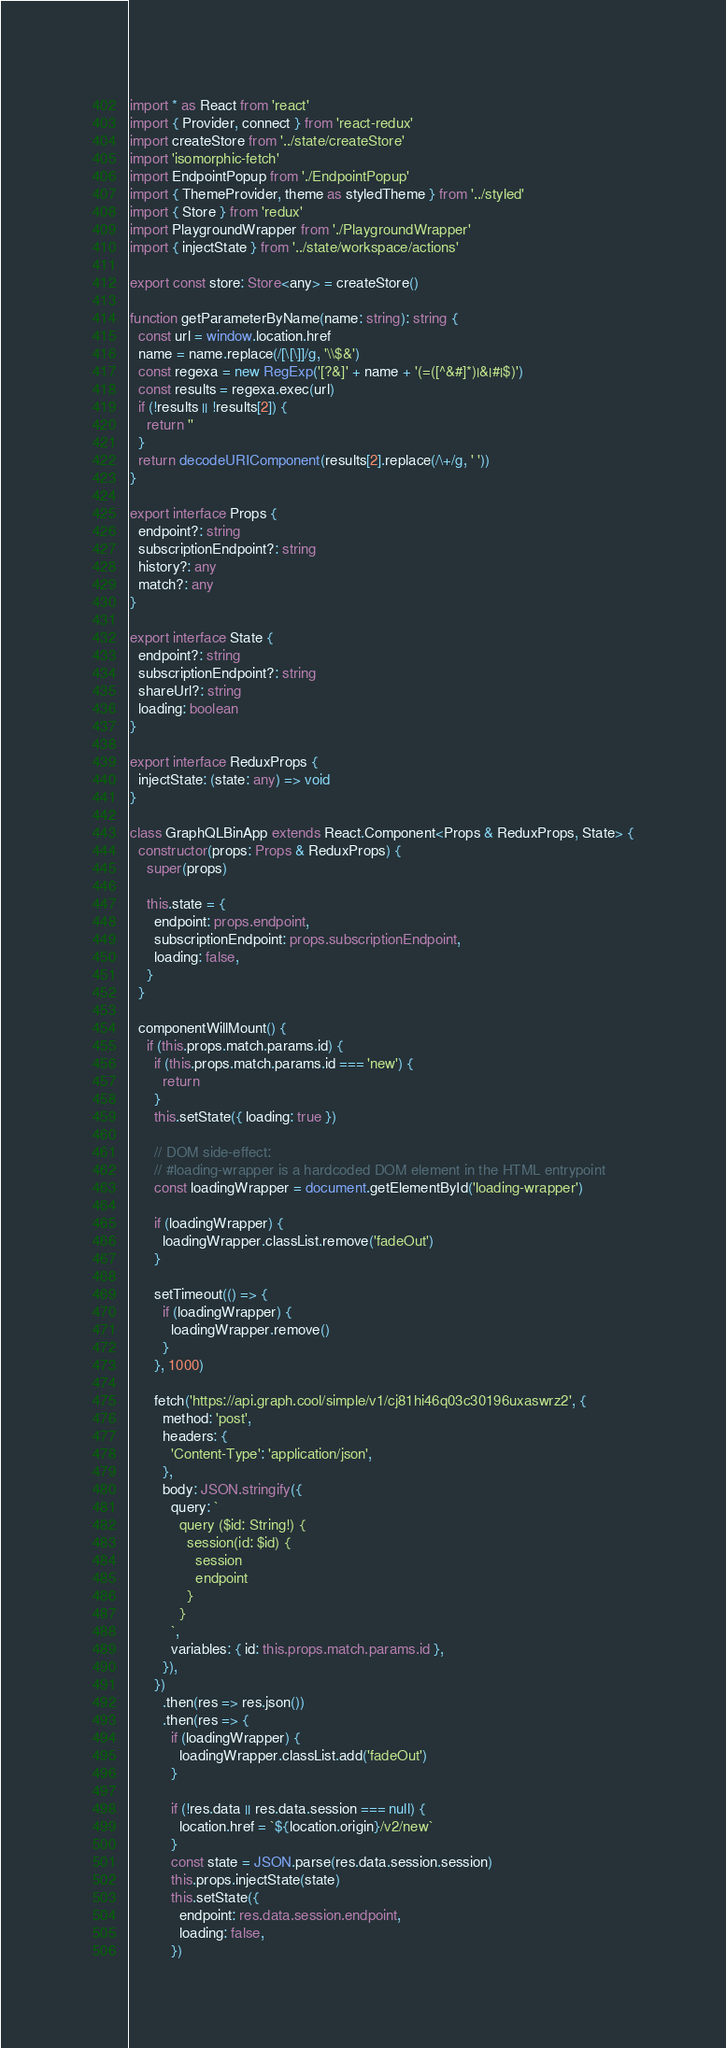Convert code to text. <code><loc_0><loc_0><loc_500><loc_500><_TypeScript_>import * as React from 'react'
import { Provider, connect } from 'react-redux'
import createStore from '../state/createStore'
import 'isomorphic-fetch'
import EndpointPopup from './EndpointPopup'
import { ThemeProvider, theme as styledTheme } from '../styled'
import { Store } from 'redux'
import PlaygroundWrapper from './PlaygroundWrapper'
import { injectState } from '../state/workspace/actions'

export const store: Store<any> = createStore()

function getParameterByName(name: string): string {
  const url = window.location.href
  name = name.replace(/[\[\]]/g, '\\$&')
  const regexa = new RegExp('[?&]' + name + '(=([^&#]*)|&|#|$)')
  const results = regexa.exec(url)
  if (!results || !results[2]) {
    return ''
  }
  return decodeURIComponent(results[2].replace(/\+/g, ' '))
}

export interface Props {
  endpoint?: string
  subscriptionEndpoint?: string
  history?: any
  match?: any
}

export interface State {
  endpoint?: string
  subscriptionEndpoint?: string
  shareUrl?: string
  loading: boolean
}

export interface ReduxProps {
  injectState: (state: any) => void
}

class GraphQLBinApp extends React.Component<Props & ReduxProps, State> {
  constructor(props: Props & ReduxProps) {
    super(props)

    this.state = {
      endpoint: props.endpoint,
      subscriptionEndpoint: props.subscriptionEndpoint,
      loading: false,
    }
  }

  componentWillMount() {
    if (this.props.match.params.id) {
      if (this.props.match.params.id === 'new') {
        return
      }
      this.setState({ loading: true })

      // DOM side-effect:
      // #loading-wrapper is a hardcoded DOM element in the HTML entrypoint
      const loadingWrapper = document.getElementById('loading-wrapper')

      if (loadingWrapper) {
        loadingWrapper.classList.remove('fadeOut')
      }

      setTimeout(() => {
        if (loadingWrapper) {
          loadingWrapper.remove()
        }
      }, 1000)

      fetch('https://api.graph.cool/simple/v1/cj81hi46q03c30196uxaswrz2', {
        method: 'post',
        headers: {
          'Content-Type': 'application/json',
        },
        body: JSON.stringify({
          query: `
            query ($id: String!) {
              session(id: $id) {
                session
                endpoint
              }
            }
          `,
          variables: { id: this.props.match.params.id },
        }),
      })
        .then(res => res.json())
        .then(res => {
          if (loadingWrapper) {
            loadingWrapper.classList.add('fadeOut')
          }

          if (!res.data || res.data.session === null) {
            location.href = `${location.origin}/v2/new`
          }
          const state = JSON.parse(res.data.session.session)
          this.props.injectState(state)
          this.setState({
            endpoint: res.data.session.endpoint,
            loading: false,
          })</code> 